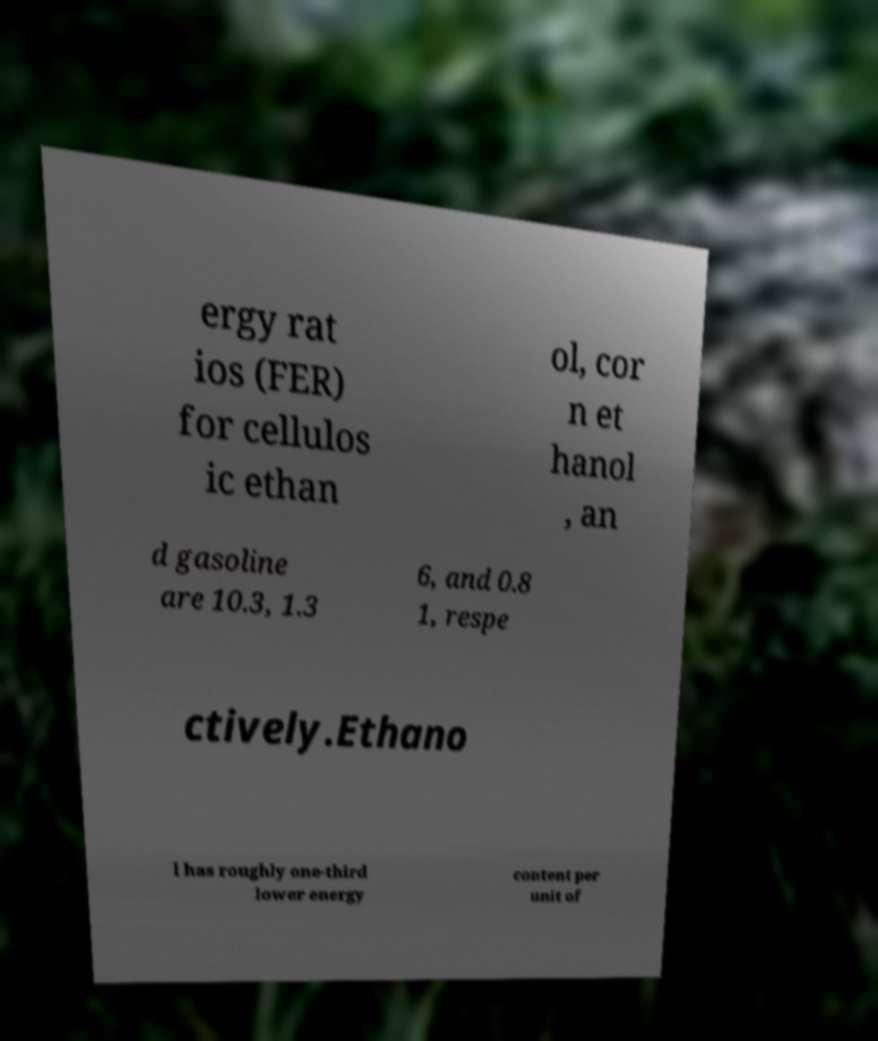Could you extract and type out the text from this image? ergy rat ios (FER) for cellulos ic ethan ol, cor n et hanol , an d gasoline are 10.3, 1.3 6, and 0.8 1, respe ctively.Ethano l has roughly one-third lower energy content per unit of 